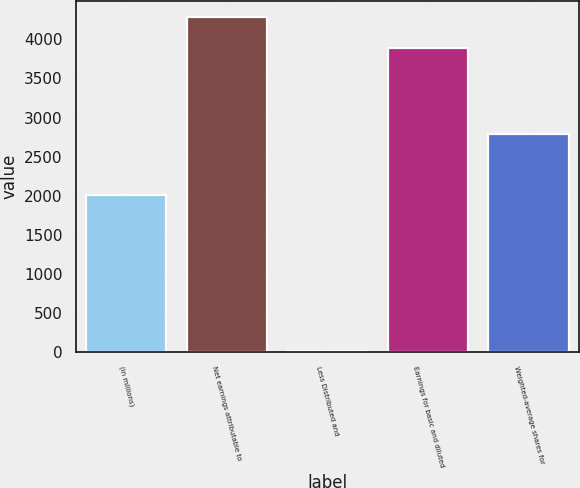Convert chart to OTSL. <chart><loc_0><loc_0><loc_500><loc_500><bar_chart><fcel>(in millions)<fcel>Net earnings attributable to<fcel>Less Distributed and<fcel>Earnings for basic and diluted<fcel>Weighted-average shares for<nl><fcel>2010<fcel>4279<fcel>15<fcel>3890<fcel>2788<nl></chart> 